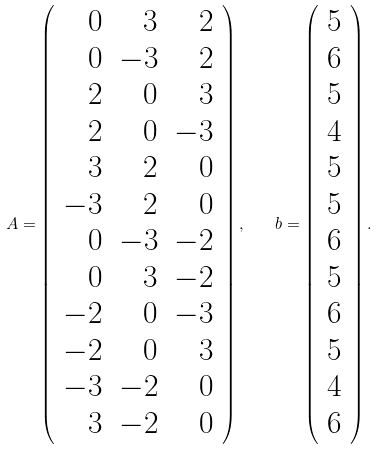Convert formula to latex. <formula><loc_0><loc_0><loc_500><loc_500>A = \left ( \begin{array} { r r r } 0 & 3 & 2 \\ 0 & - 3 & 2 \\ 2 & 0 & 3 \\ 2 & 0 & - 3 \\ 3 & 2 & 0 \\ - 3 & 2 & 0 \\ 0 & - 3 & - 2 \\ 0 & 3 & - 2 \\ - 2 & 0 & - 3 \\ - 2 & 0 & 3 \\ - 3 & - 2 & 0 \\ 3 & - 2 & 0 \end{array} \right ) , \quad b = \left ( \begin{array} { r } 5 \\ 6 \\ 5 \\ 4 \\ 5 \\ 5 \\ 6 \\ 5 \\ 6 \\ 5 \\ 4 \\ 6 \end{array} \right ) .</formula> 